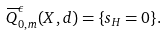Convert formula to latex. <formula><loc_0><loc_0><loc_500><loc_500>\overline { Q } _ { 0 , m } ^ { \epsilon } ( X , d ) = \{ s _ { H } = 0 \} .</formula> 